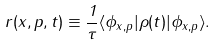<formula> <loc_0><loc_0><loc_500><loc_500>r ( { x } , { p } , t ) \equiv \frac { 1 } { \tau } \langle \phi _ { { x } , { p } } | \rho ( t ) | \phi _ { { x } , { p } } \rangle .</formula> 